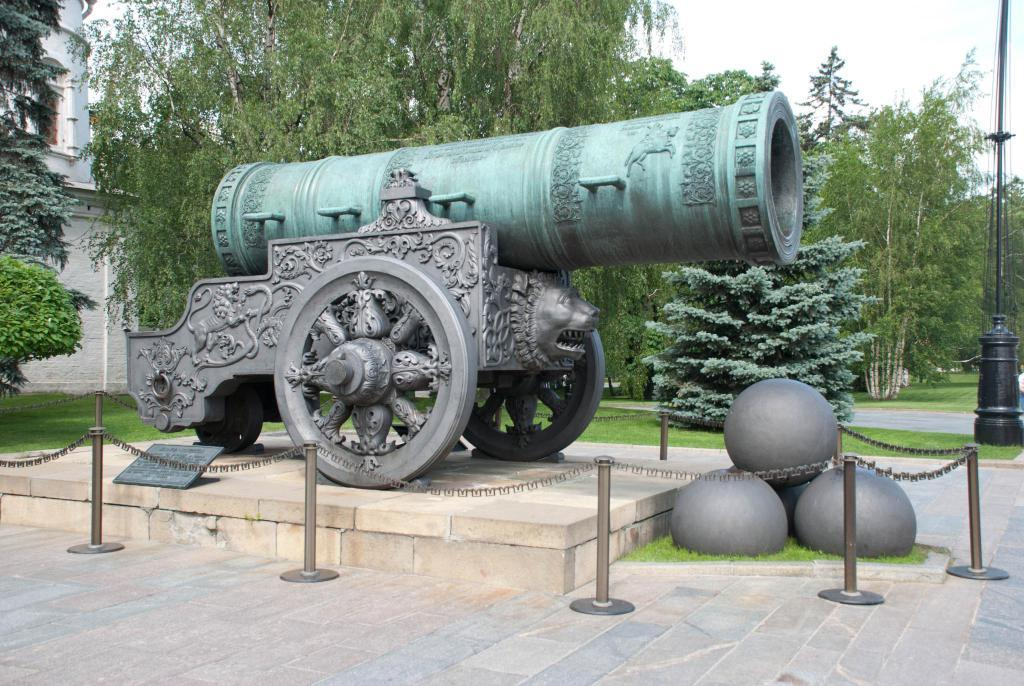What is the main subject of the image? There is a sculpture of a cannon in the image. What can be seen in the background of the image? There are trees, a building, and a black color pole in the background of the image. How many friends are holding corks in the image? There are no friends or corks present in the image. What part of the body is missing from the cannon in the image? The cannon is a sculpture and does not have a body or parts, so there is no missing arm or any other body part. 